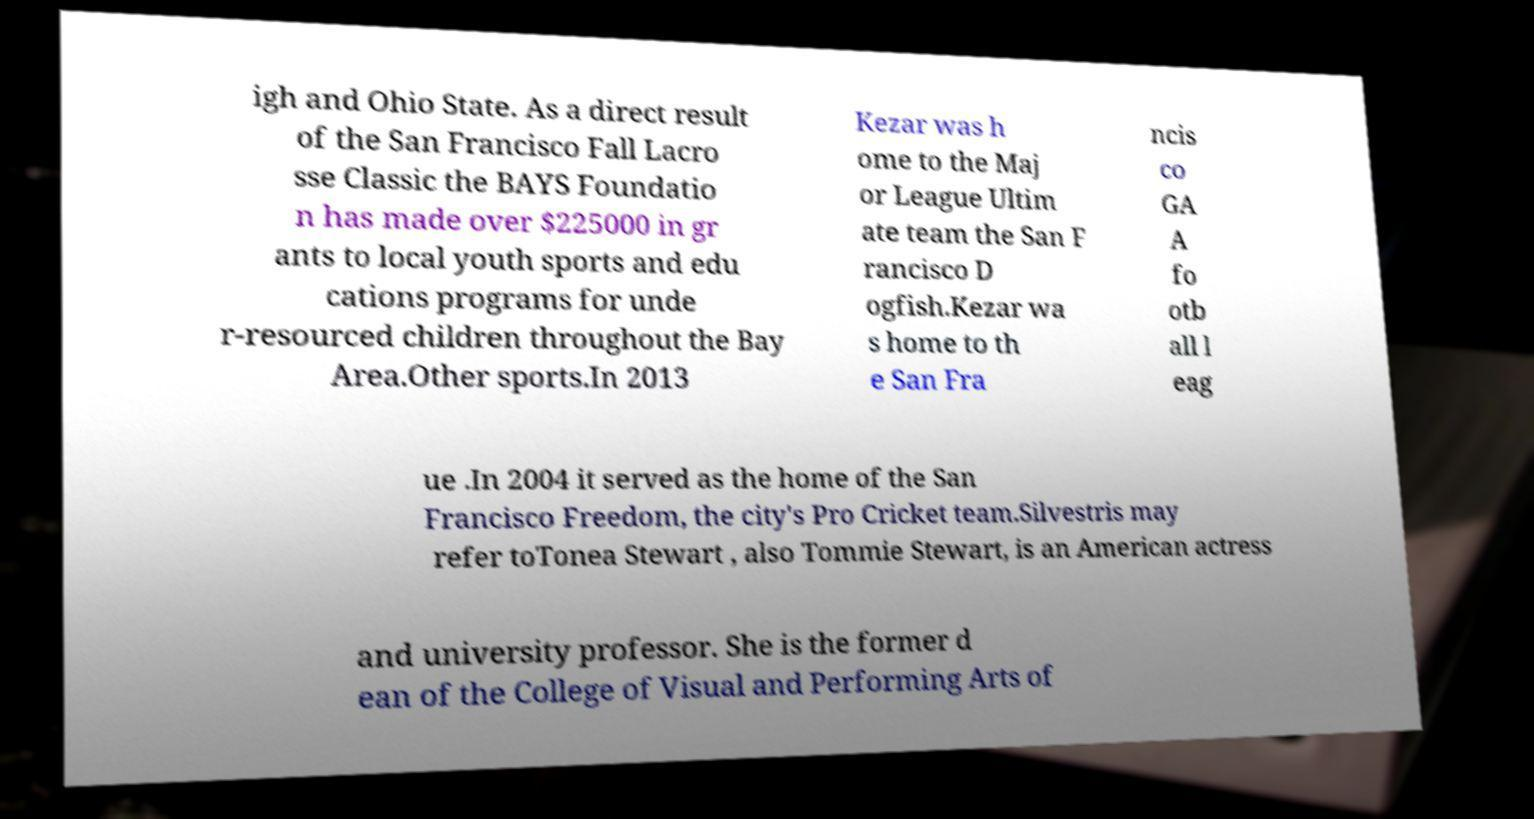Could you extract and type out the text from this image? igh and Ohio State. As a direct result of the San Francisco Fall Lacro sse Classic the BAYS Foundatio n has made over $225000 in gr ants to local youth sports and edu cations programs for unde r-resourced children throughout the Bay Area.Other sports.In 2013 Kezar was h ome to the Maj or League Ultim ate team the San F rancisco D ogfish.Kezar wa s home to th e San Fra ncis co GA A fo otb all l eag ue .In 2004 it served as the home of the San Francisco Freedom, the city's Pro Cricket team.Silvestris may refer toTonea Stewart , also Tommie Stewart, is an American actress and university professor. She is the former d ean of the College of Visual and Performing Arts of 